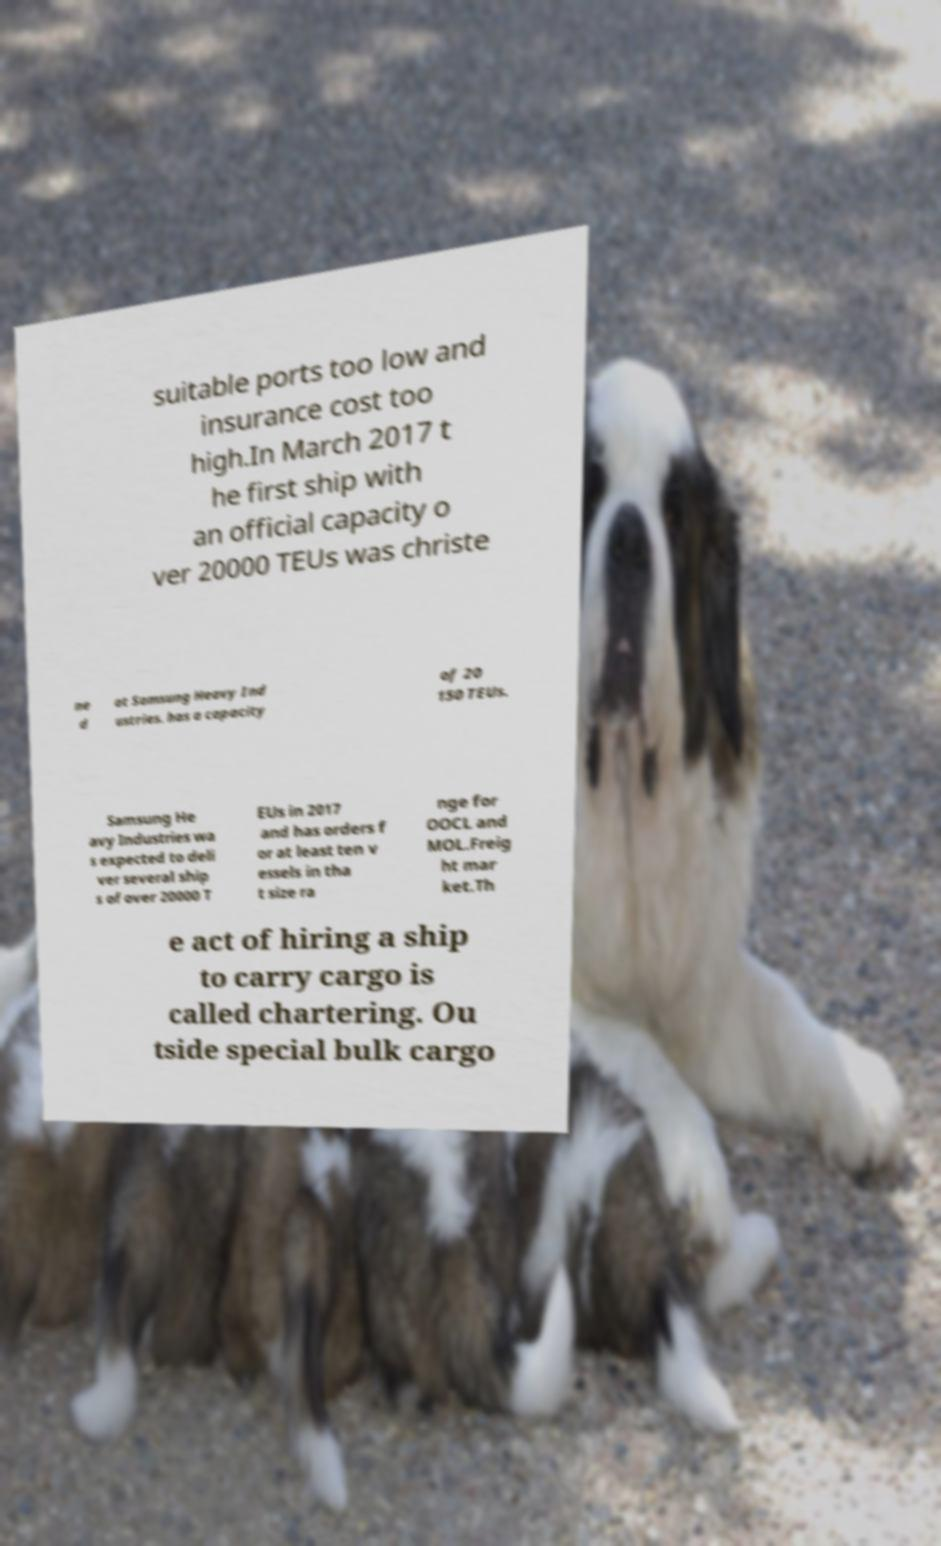Can you read and provide the text displayed in the image?This photo seems to have some interesting text. Can you extract and type it out for me? suitable ports too low and insurance cost too high.In March 2017 t he first ship with an official capacity o ver 20000 TEUs was christe ne d at Samsung Heavy Ind ustries. has a capacity of 20 150 TEUs. Samsung He avy Industries wa s expected to deli ver several ship s of over 20000 T EUs in 2017 and has orders f or at least ten v essels in tha t size ra nge for OOCL and MOL.Freig ht mar ket.Th e act of hiring a ship to carry cargo is called chartering. Ou tside special bulk cargo 